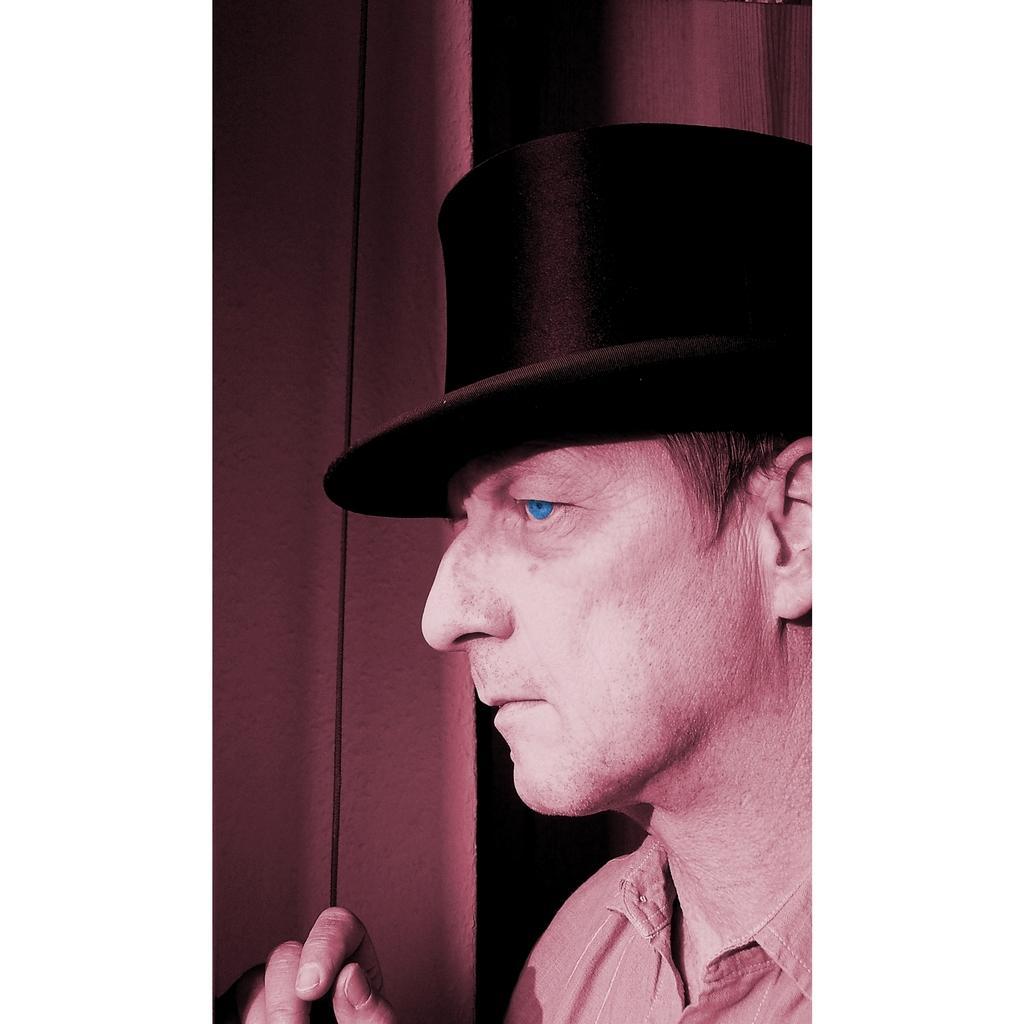Please provide a concise description of this image. In this image, I can see the man. He wore a hat and shirt. 